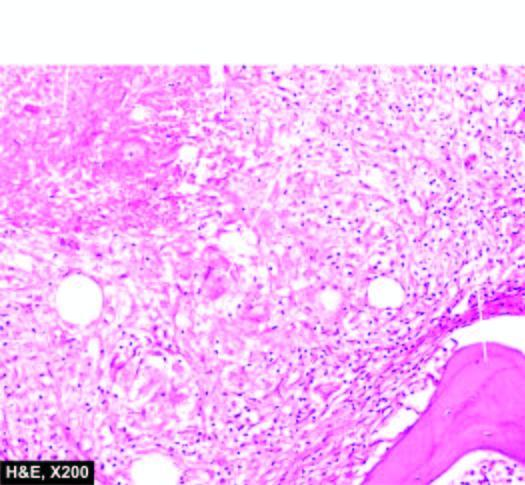re a partly formed unerupted tooth epithelioid cell granulomas with minute areas of caseation necrosis and surrounded by langhans ' giant cells?
Answer the question using a single word or phrase. No 